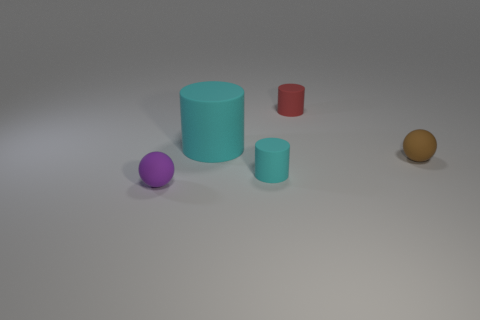Add 4 large cyan cylinders. How many objects exist? 9 Subtract all balls. How many objects are left? 3 Add 1 tiny brown things. How many tiny brown things are left? 2 Add 3 rubber balls. How many rubber balls exist? 5 Subtract 0 green balls. How many objects are left? 5 Subtract all tiny red spheres. Subtract all tiny purple matte balls. How many objects are left? 4 